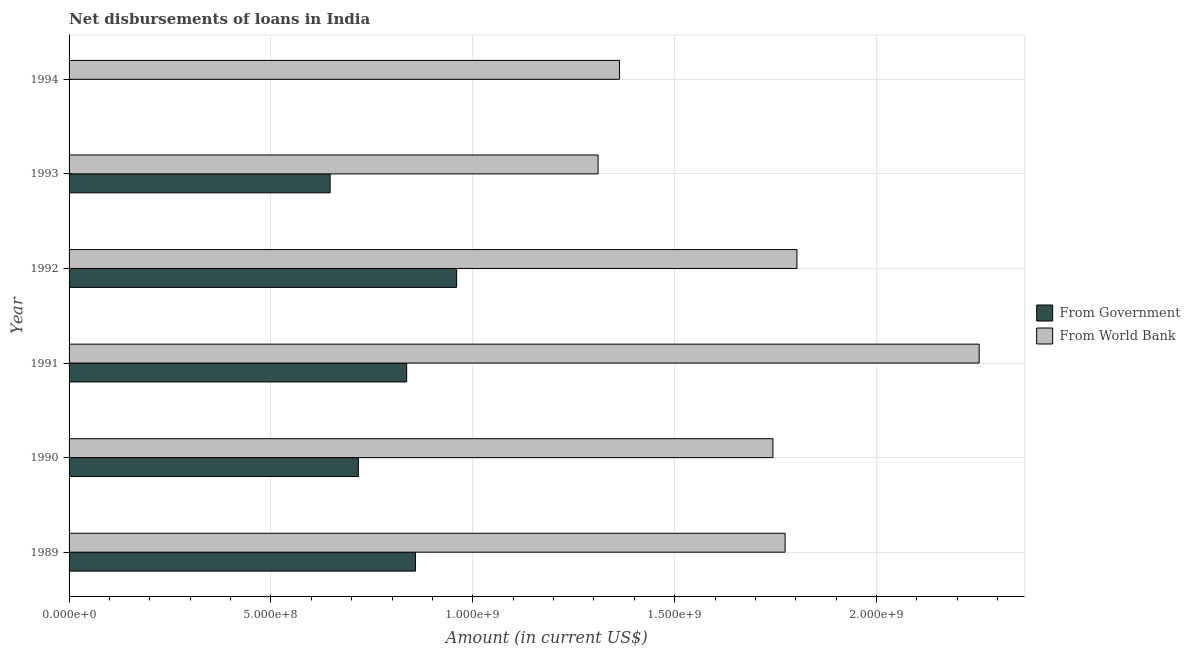How many bars are there on the 1st tick from the bottom?
Give a very brief answer. 2. What is the label of the 5th group of bars from the top?
Your answer should be compact. 1990. In how many cases, is the number of bars for a given year not equal to the number of legend labels?
Offer a terse response. 1. What is the net disbursements of loan from government in 1990?
Ensure brevity in your answer.  7.17e+08. Across all years, what is the maximum net disbursements of loan from world bank?
Offer a very short reply. 2.25e+09. Across all years, what is the minimum net disbursements of loan from world bank?
Offer a very short reply. 1.31e+09. In which year was the net disbursements of loan from government maximum?
Provide a short and direct response. 1992. What is the total net disbursements of loan from world bank in the graph?
Give a very brief answer. 1.02e+1. What is the difference between the net disbursements of loan from world bank in 1990 and that in 1992?
Keep it short and to the point. -5.96e+07. What is the difference between the net disbursements of loan from government in 1991 and the net disbursements of loan from world bank in 1993?
Your answer should be compact. -4.74e+08. What is the average net disbursements of loan from government per year?
Offer a very short reply. 6.70e+08. In the year 1989, what is the difference between the net disbursements of loan from world bank and net disbursements of loan from government?
Give a very brief answer. 9.16e+08. What is the ratio of the net disbursements of loan from world bank in 1989 to that in 1994?
Offer a terse response. 1.3. Is the net disbursements of loan from world bank in 1992 less than that in 1993?
Ensure brevity in your answer.  No. Is the difference between the net disbursements of loan from government in 1992 and 1993 greater than the difference between the net disbursements of loan from world bank in 1992 and 1993?
Your response must be concise. No. What is the difference between the highest and the second highest net disbursements of loan from government?
Give a very brief answer. 1.02e+08. What is the difference between the highest and the lowest net disbursements of loan from world bank?
Give a very brief answer. 9.44e+08. In how many years, is the net disbursements of loan from world bank greater than the average net disbursements of loan from world bank taken over all years?
Give a very brief answer. 4. Is the sum of the net disbursements of loan from world bank in 1989 and 1990 greater than the maximum net disbursements of loan from government across all years?
Ensure brevity in your answer.  Yes. How many bars are there?
Provide a short and direct response. 11. Are all the bars in the graph horizontal?
Keep it short and to the point. Yes. How many years are there in the graph?
Ensure brevity in your answer.  6. Are the values on the major ticks of X-axis written in scientific E-notation?
Keep it short and to the point. Yes. Does the graph contain any zero values?
Your answer should be compact. Yes. Does the graph contain grids?
Provide a short and direct response. Yes. How many legend labels are there?
Your answer should be compact. 2. How are the legend labels stacked?
Ensure brevity in your answer.  Vertical. What is the title of the graph?
Keep it short and to the point. Net disbursements of loans in India. What is the Amount (in current US$) in From Government in 1989?
Provide a short and direct response. 8.58e+08. What is the Amount (in current US$) of From World Bank in 1989?
Make the answer very short. 1.77e+09. What is the Amount (in current US$) of From Government in 1990?
Give a very brief answer. 7.17e+08. What is the Amount (in current US$) of From World Bank in 1990?
Your answer should be very brief. 1.74e+09. What is the Amount (in current US$) in From Government in 1991?
Your response must be concise. 8.36e+08. What is the Amount (in current US$) of From World Bank in 1991?
Your answer should be compact. 2.25e+09. What is the Amount (in current US$) of From Government in 1992?
Your answer should be very brief. 9.60e+08. What is the Amount (in current US$) of From World Bank in 1992?
Give a very brief answer. 1.80e+09. What is the Amount (in current US$) of From Government in 1993?
Provide a short and direct response. 6.47e+08. What is the Amount (in current US$) in From World Bank in 1993?
Keep it short and to the point. 1.31e+09. What is the Amount (in current US$) in From Government in 1994?
Give a very brief answer. 0. What is the Amount (in current US$) of From World Bank in 1994?
Keep it short and to the point. 1.36e+09. Across all years, what is the maximum Amount (in current US$) of From Government?
Ensure brevity in your answer.  9.60e+08. Across all years, what is the maximum Amount (in current US$) in From World Bank?
Give a very brief answer. 2.25e+09. Across all years, what is the minimum Amount (in current US$) of From Government?
Offer a very short reply. 0. Across all years, what is the minimum Amount (in current US$) in From World Bank?
Provide a succinct answer. 1.31e+09. What is the total Amount (in current US$) in From Government in the graph?
Keep it short and to the point. 4.02e+09. What is the total Amount (in current US$) of From World Bank in the graph?
Keep it short and to the point. 1.02e+1. What is the difference between the Amount (in current US$) of From Government in 1989 and that in 1990?
Give a very brief answer. 1.41e+08. What is the difference between the Amount (in current US$) of From World Bank in 1989 and that in 1990?
Your answer should be very brief. 3.02e+07. What is the difference between the Amount (in current US$) of From Government in 1989 and that in 1991?
Provide a succinct answer. 2.17e+07. What is the difference between the Amount (in current US$) in From World Bank in 1989 and that in 1991?
Your answer should be very brief. -4.81e+08. What is the difference between the Amount (in current US$) in From Government in 1989 and that in 1992?
Your response must be concise. -1.02e+08. What is the difference between the Amount (in current US$) in From World Bank in 1989 and that in 1992?
Your answer should be compact. -2.93e+07. What is the difference between the Amount (in current US$) of From Government in 1989 and that in 1993?
Give a very brief answer. 2.11e+08. What is the difference between the Amount (in current US$) in From World Bank in 1989 and that in 1993?
Ensure brevity in your answer.  4.63e+08. What is the difference between the Amount (in current US$) in From World Bank in 1989 and that in 1994?
Your answer should be compact. 4.10e+08. What is the difference between the Amount (in current US$) of From Government in 1990 and that in 1991?
Make the answer very short. -1.20e+08. What is the difference between the Amount (in current US$) of From World Bank in 1990 and that in 1991?
Provide a short and direct response. -5.11e+08. What is the difference between the Amount (in current US$) of From Government in 1990 and that in 1992?
Your answer should be compact. -2.43e+08. What is the difference between the Amount (in current US$) of From World Bank in 1990 and that in 1992?
Ensure brevity in your answer.  -5.96e+07. What is the difference between the Amount (in current US$) in From Government in 1990 and that in 1993?
Make the answer very short. 7.00e+07. What is the difference between the Amount (in current US$) of From World Bank in 1990 and that in 1993?
Your answer should be very brief. 4.33e+08. What is the difference between the Amount (in current US$) in From World Bank in 1990 and that in 1994?
Ensure brevity in your answer.  3.80e+08. What is the difference between the Amount (in current US$) in From Government in 1991 and that in 1992?
Provide a short and direct response. -1.24e+08. What is the difference between the Amount (in current US$) in From World Bank in 1991 and that in 1992?
Ensure brevity in your answer.  4.51e+08. What is the difference between the Amount (in current US$) in From Government in 1991 and that in 1993?
Offer a very short reply. 1.90e+08. What is the difference between the Amount (in current US$) in From World Bank in 1991 and that in 1993?
Your response must be concise. 9.44e+08. What is the difference between the Amount (in current US$) in From World Bank in 1991 and that in 1994?
Give a very brief answer. 8.91e+08. What is the difference between the Amount (in current US$) of From Government in 1992 and that in 1993?
Provide a short and direct response. 3.13e+08. What is the difference between the Amount (in current US$) of From World Bank in 1992 and that in 1993?
Your answer should be compact. 4.93e+08. What is the difference between the Amount (in current US$) in From World Bank in 1992 and that in 1994?
Make the answer very short. 4.40e+08. What is the difference between the Amount (in current US$) of From World Bank in 1993 and that in 1994?
Provide a succinct answer. -5.29e+07. What is the difference between the Amount (in current US$) of From Government in 1989 and the Amount (in current US$) of From World Bank in 1990?
Ensure brevity in your answer.  -8.85e+08. What is the difference between the Amount (in current US$) of From Government in 1989 and the Amount (in current US$) of From World Bank in 1991?
Your answer should be compact. -1.40e+09. What is the difference between the Amount (in current US$) in From Government in 1989 and the Amount (in current US$) in From World Bank in 1992?
Your answer should be compact. -9.45e+08. What is the difference between the Amount (in current US$) of From Government in 1989 and the Amount (in current US$) of From World Bank in 1993?
Provide a succinct answer. -4.52e+08. What is the difference between the Amount (in current US$) in From Government in 1989 and the Amount (in current US$) in From World Bank in 1994?
Give a very brief answer. -5.05e+08. What is the difference between the Amount (in current US$) in From Government in 1990 and the Amount (in current US$) in From World Bank in 1991?
Give a very brief answer. -1.54e+09. What is the difference between the Amount (in current US$) in From Government in 1990 and the Amount (in current US$) in From World Bank in 1992?
Provide a short and direct response. -1.09e+09. What is the difference between the Amount (in current US$) of From Government in 1990 and the Amount (in current US$) of From World Bank in 1993?
Your response must be concise. -5.94e+08. What is the difference between the Amount (in current US$) of From Government in 1990 and the Amount (in current US$) of From World Bank in 1994?
Give a very brief answer. -6.47e+08. What is the difference between the Amount (in current US$) of From Government in 1991 and the Amount (in current US$) of From World Bank in 1992?
Ensure brevity in your answer.  -9.67e+08. What is the difference between the Amount (in current US$) in From Government in 1991 and the Amount (in current US$) in From World Bank in 1993?
Offer a terse response. -4.74e+08. What is the difference between the Amount (in current US$) of From Government in 1991 and the Amount (in current US$) of From World Bank in 1994?
Provide a short and direct response. -5.27e+08. What is the difference between the Amount (in current US$) in From Government in 1992 and the Amount (in current US$) in From World Bank in 1993?
Your response must be concise. -3.50e+08. What is the difference between the Amount (in current US$) in From Government in 1992 and the Amount (in current US$) in From World Bank in 1994?
Provide a short and direct response. -4.03e+08. What is the difference between the Amount (in current US$) of From Government in 1993 and the Amount (in current US$) of From World Bank in 1994?
Offer a very short reply. -7.17e+08. What is the average Amount (in current US$) of From Government per year?
Make the answer very short. 6.70e+08. What is the average Amount (in current US$) of From World Bank per year?
Make the answer very short. 1.71e+09. In the year 1989, what is the difference between the Amount (in current US$) of From Government and Amount (in current US$) of From World Bank?
Your answer should be compact. -9.16e+08. In the year 1990, what is the difference between the Amount (in current US$) of From Government and Amount (in current US$) of From World Bank?
Your answer should be very brief. -1.03e+09. In the year 1991, what is the difference between the Amount (in current US$) in From Government and Amount (in current US$) in From World Bank?
Make the answer very short. -1.42e+09. In the year 1992, what is the difference between the Amount (in current US$) in From Government and Amount (in current US$) in From World Bank?
Ensure brevity in your answer.  -8.43e+08. In the year 1993, what is the difference between the Amount (in current US$) in From Government and Amount (in current US$) in From World Bank?
Provide a succinct answer. -6.64e+08. What is the ratio of the Amount (in current US$) in From Government in 1989 to that in 1990?
Give a very brief answer. 1.2. What is the ratio of the Amount (in current US$) of From World Bank in 1989 to that in 1990?
Give a very brief answer. 1.02. What is the ratio of the Amount (in current US$) in From Government in 1989 to that in 1991?
Ensure brevity in your answer.  1.03. What is the ratio of the Amount (in current US$) in From World Bank in 1989 to that in 1991?
Keep it short and to the point. 0.79. What is the ratio of the Amount (in current US$) of From Government in 1989 to that in 1992?
Offer a very short reply. 0.89. What is the ratio of the Amount (in current US$) of From World Bank in 1989 to that in 1992?
Offer a terse response. 0.98. What is the ratio of the Amount (in current US$) of From Government in 1989 to that in 1993?
Provide a short and direct response. 1.33. What is the ratio of the Amount (in current US$) in From World Bank in 1989 to that in 1993?
Offer a very short reply. 1.35. What is the ratio of the Amount (in current US$) in From World Bank in 1989 to that in 1994?
Offer a terse response. 1.3. What is the ratio of the Amount (in current US$) in From Government in 1990 to that in 1991?
Your answer should be compact. 0.86. What is the ratio of the Amount (in current US$) of From World Bank in 1990 to that in 1991?
Offer a very short reply. 0.77. What is the ratio of the Amount (in current US$) of From Government in 1990 to that in 1992?
Make the answer very short. 0.75. What is the ratio of the Amount (in current US$) in From World Bank in 1990 to that in 1992?
Offer a very short reply. 0.97. What is the ratio of the Amount (in current US$) of From Government in 1990 to that in 1993?
Make the answer very short. 1.11. What is the ratio of the Amount (in current US$) of From World Bank in 1990 to that in 1993?
Provide a succinct answer. 1.33. What is the ratio of the Amount (in current US$) in From World Bank in 1990 to that in 1994?
Provide a short and direct response. 1.28. What is the ratio of the Amount (in current US$) in From Government in 1991 to that in 1992?
Offer a terse response. 0.87. What is the ratio of the Amount (in current US$) of From World Bank in 1991 to that in 1992?
Offer a terse response. 1.25. What is the ratio of the Amount (in current US$) in From Government in 1991 to that in 1993?
Give a very brief answer. 1.29. What is the ratio of the Amount (in current US$) in From World Bank in 1991 to that in 1993?
Provide a succinct answer. 1.72. What is the ratio of the Amount (in current US$) of From World Bank in 1991 to that in 1994?
Offer a terse response. 1.65. What is the ratio of the Amount (in current US$) of From Government in 1992 to that in 1993?
Offer a very short reply. 1.48. What is the ratio of the Amount (in current US$) of From World Bank in 1992 to that in 1993?
Provide a short and direct response. 1.38. What is the ratio of the Amount (in current US$) of From World Bank in 1992 to that in 1994?
Provide a short and direct response. 1.32. What is the ratio of the Amount (in current US$) of From World Bank in 1993 to that in 1994?
Offer a very short reply. 0.96. What is the difference between the highest and the second highest Amount (in current US$) in From Government?
Make the answer very short. 1.02e+08. What is the difference between the highest and the second highest Amount (in current US$) in From World Bank?
Keep it short and to the point. 4.51e+08. What is the difference between the highest and the lowest Amount (in current US$) of From Government?
Keep it short and to the point. 9.60e+08. What is the difference between the highest and the lowest Amount (in current US$) of From World Bank?
Your answer should be compact. 9.44e+08. 